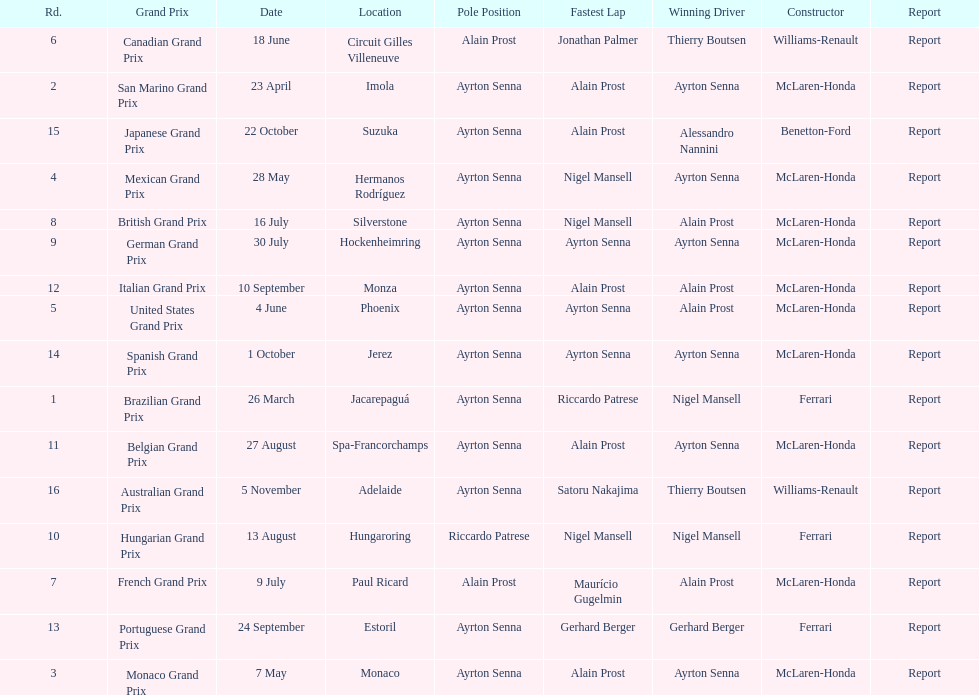What grand prix was before the san marino grand prix? Brazilian Grand Prix. Would you be able to parse every entry in this table? {'header': ['Rd.', 'Grand Prix', 'Date', 'Location', 'Pole Position', 'Fastest Lap', 'Winning Driver', 'Constructor', 'Report'], 'rows': [['6', 'Canadian Grand Prix', '18 June', 'Circuit Gilles Villeneuve', 'Alain Prost', 'Jonathan Palmer', 'Thierry Boutsen', 'Williams-Renault', 'Report'], ['2', 'San Marino Grand Prix', '23 April', 'Imola', 'Ayrton Senna', 'Alain Prost', 'Ayrton Senna', 'McLaren-Honda', 'Report'], ['15', 'Japanese Grand Prix', '22 October', 'Suzuka', 'Ayrton Senna', 'Alain Prost', 'Alessandro Nannini', 'Benetton-Ford', 'Report'], ['4', 'Mexican Grand Prix', '28 May', 'Hermanos Rodríguez', 'Ayrton Senna', 'Nigel Mansell', 'Ayrton Senna', 'McLaren-Honda', 'Report'], ['8', 'British Grand Prix', '16 July', 'Silverstone', 'Ayrton Senna', 'Nigel Mansell', 'Alain Prost', 'McLaren-Honda', 'Report'], ['9', 'German Grand Prix', '30 July', 'Hockenheimring', 'Ayrton Senna', 'Ayrton Senna', 'Ayrton Senna', 'McLaren-Honda', 'Report'], ['12', 'Italian Grand Prix', '10 September', 'Monza', 'Ayrton Senna', 'Alain Prost', 'Alain Prost', 'McLaren-Honda', 'Report'], ['5', 'United States Grand Prix', '4 June', 'Phoenix', 'Ayrton Senna', 'Ayrton Senna', 'Alain Prost', 'McLaren-Honda', 'Report'], ['14', 'Spanish Grand Prix', '1 October', 'Jerez', 'Ayrton Senna', 'Ayrton Senna', 'Ayrton Senna', 'McLaren-Honda', 'Report'], ['1', 'Brazilian Grand Prix', '26 March', 'Jacarepaguá', 'Ayrton Senna', 'Riccardo Patrese', 'Nigel Mansell', 'Ferrari', 'Report'], ['11', 'Belgian Grand Prix', '27 August', 'Spa-Francorchamps', 'Ayrton Senna', 'Alain Prost', 'Ayrton Senna', 'McLaren-Honda', 'Report'], ['16', 'Australian Grand Prix', '5 November', 'Adelaide', 'Ayrton Senna', 'Satoru Nakajima', 'Thierry Boutsen', 'Williams-Renault', 'Report'], ['10', 'Hungarian Grand Prix', '13 August', 'Hungaroring', 'Riccardo Patrese', 'Nigel Mansell', 'Nigel Mansell', 'Ferrari', 'Report'], ['7', 'French Grand Prix', '9 July', 'Paul Ricard', 'Alain Prost', 'Maurício Gugelmin', 'Alain Prost', 'McLaren-Honda', 'Report'], ['13', 'Portuguese Grand Prix', '24 September', 'Estoril', 'Ayrton Senna', 'Gerhard Berger', 'Gerhard Berger', 'Ferrari', 'Report'], ['3', 'Monaco Grand Prix', '7 May', 'Monaco', 'Ayrton Senna', 'Alain Prost', 'Ayrton Senna', 'McLaren-Honda', 'Report']]} 